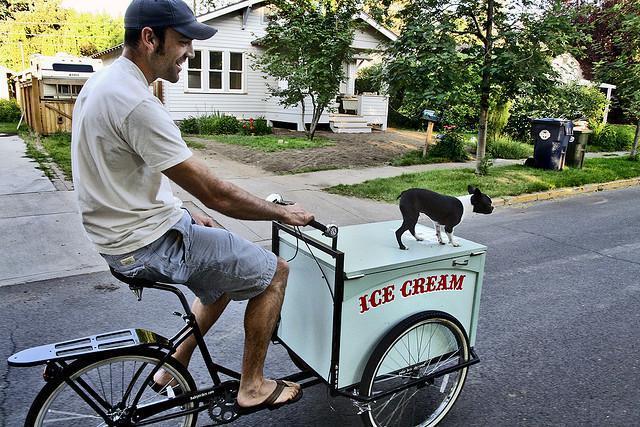Is this affirmation: "The bicycle is in front of the person." correct?
Answer yes or no. No. 